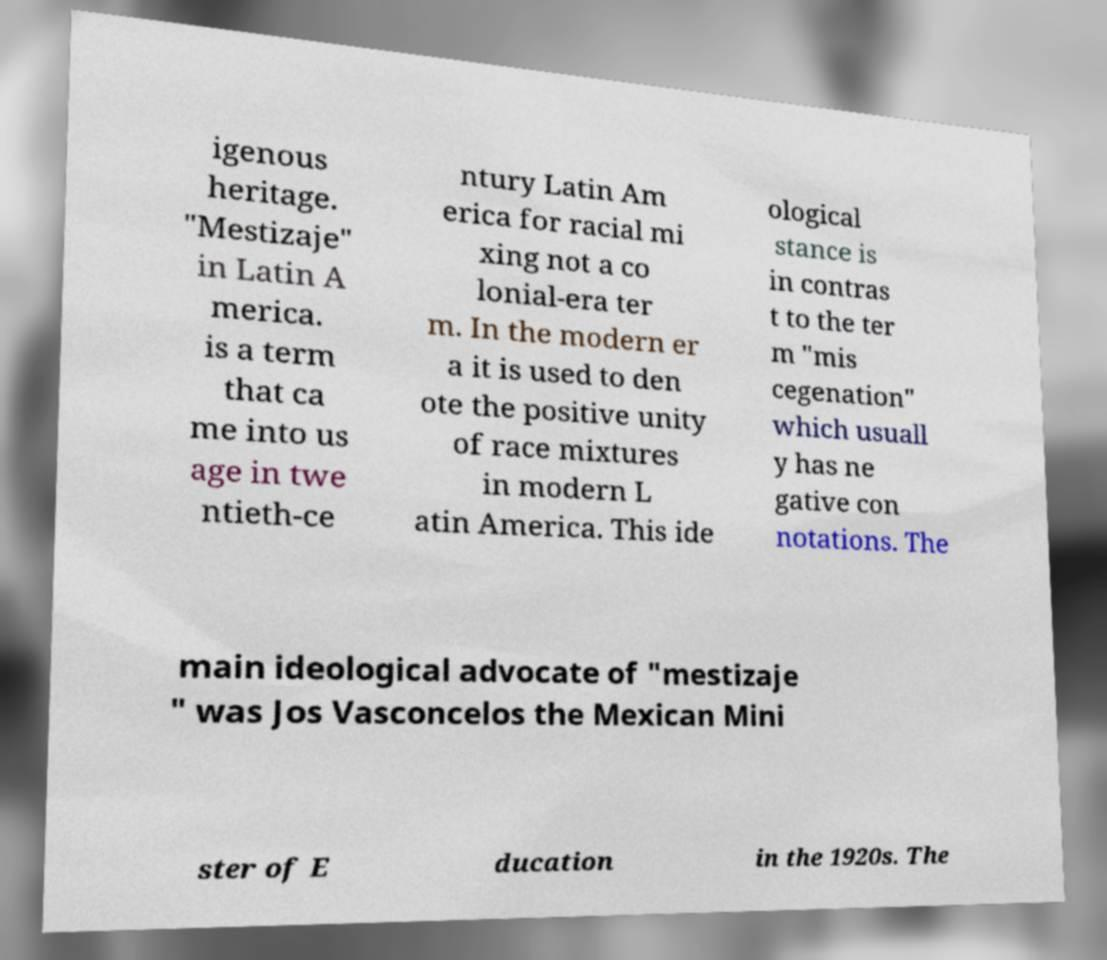Can you accurately transcribe the text from the provided image for me? igenous heritage. "Mestizaje" in Latin A merica. is a term that ca me into us age in twe ntieth-ce ntury Latin Am erica for racial mi xing not a co lonial-era ter m. In the modern er a it is used to den ote the positive unity of race mixtures in modern L atin America. This ide ological stance is in contras t to the ter m "mis cegenation" which usuall y has ne gative con notations. The main ideological advocate of "mestizaje " was Jos Vasconcelos the Mexican Mini ster of E ducation in the 1920s. The 